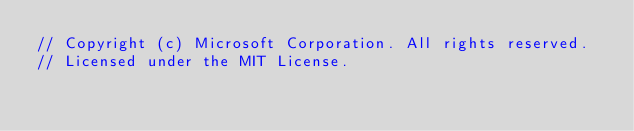Convert code to text. <code><loc_0><loc_0><loc_500><loc_500><_JavaScript_>// Copyright (c) Microsoft Corporation. All rights reserved.
// Licensed under the MIT License.</code> 